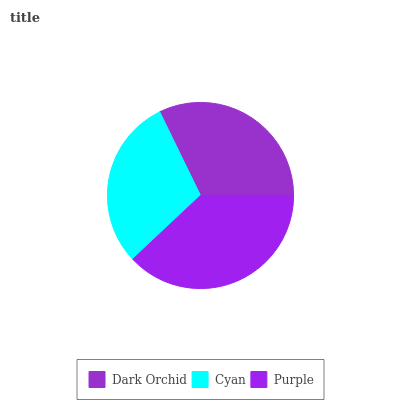Is Cyan the minimum?
Answer yes or no. Yes. Is Purple the maximum?
Answer yes or no. Yes. Is Purple the minimum?
Answer yes or no. No. Is Cyan the maximum?
Answer yes or no. No. Is Purple greater than Cyan?
Answer yes or no. Yes. Is Cyan less than Purple?
Answer yes or no. Yes. Is Cyan greater than Purple?
Answer yes or no. No. Is Purple less than Cyan?
Answer yes or no. No. Is Dark Orchid the high median?
Answer yes or no. Yes. Is Dark Orchid the low median?
Answer yes or no. Yes. Is Cyan the high median?
Answer yes or no. No. Is Purple the low median?
Answer yes or no. No. 